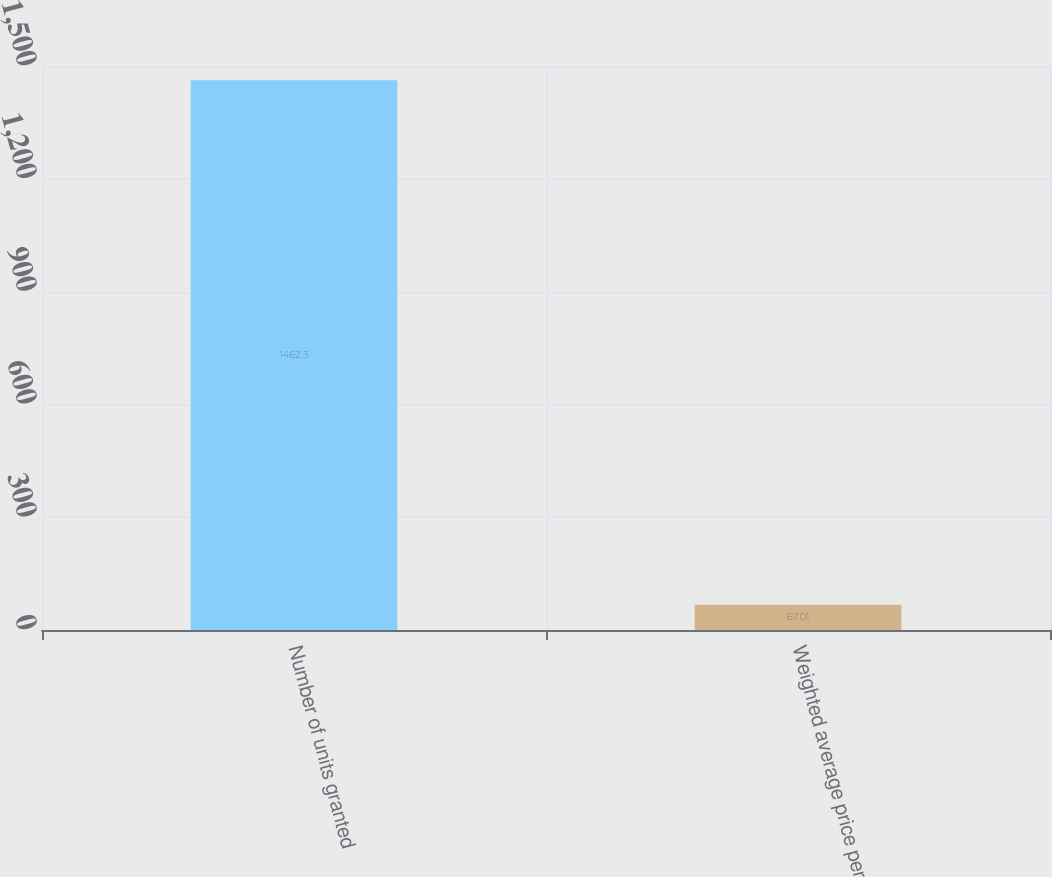<chart> <loc_0><loc_0><loc_500><loc_500><bar_chart><fcel>Number of units granted<fcel>Weighted average price per<nl><fcel>1462.3<fcel>67.01<nl></chart> 